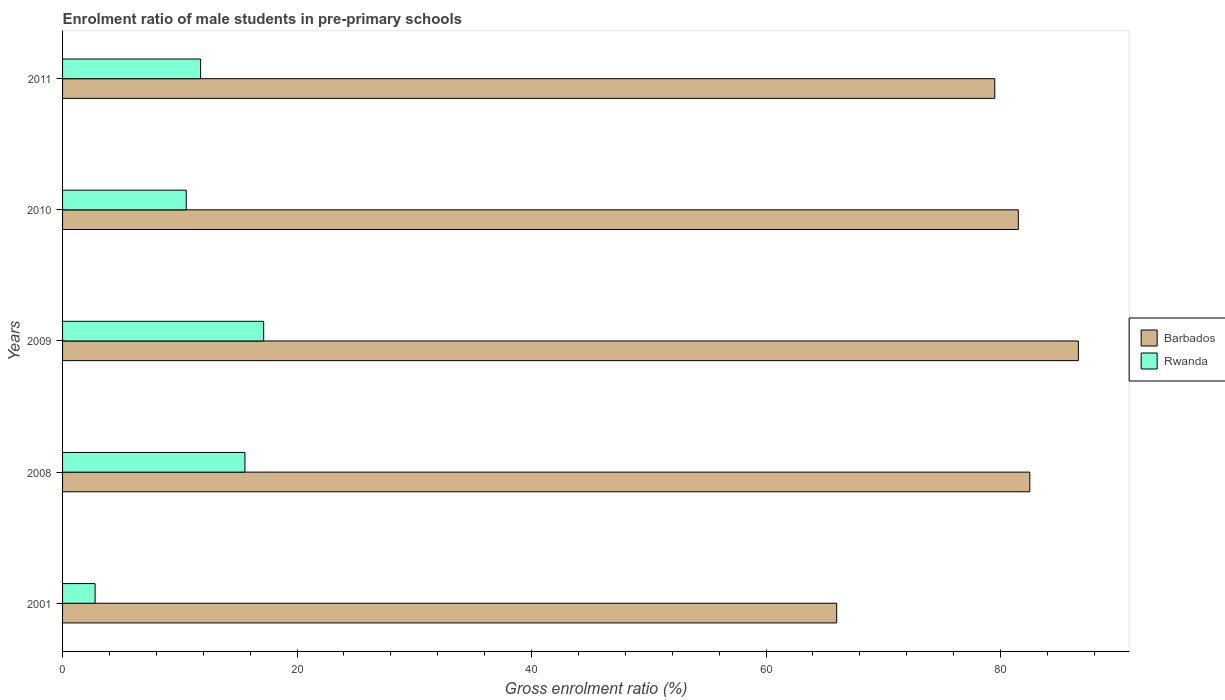How many different coloured bars are there?
Your response must be concise. 2. How many groups of bars are there?
Ensure brevity in your answer.  5. Are the number of bars per tick equal to the number of legend labels?
Offer a very short reply. Yes. What is the label of the 2nd group of bars from the top?
Ensure brevity in your answer.  2010. In how many cases, is the number of bars for a given year not equal to the number of legend labels?
Offer a very short reply. 0. What is the enrolment ratio of male students in pre-primary schools in Barbados in 2008?
Provide a succinct answer. 82.5. Across all years, what is the maximum enrolment ratio of male students in pre-primary schools in Rwanda?
Make the answer very short. 17.15. Across all years, what is the minimum enrolment ratio of male students in pre-primary schools in Rwanda?
Ensure brevity in your answer.  2.78. In which year was the enrolment ratio of male students in pre-primary schools in Barbados maximum?
Your response must be concise. 2009. What is the total enrolment ratio of male students in pre-primary schools in Rwanda in the graph?
Keep it short and to the point. 57.8. What is the difference between the enrolment ratio of male students in pre-primary schools in Rwanda in 2008 and that in 2011?
Provide a short and direct response. 3.78. What is the difference between the enrolment ratio of male students in pre-primary schools in Barbados in 2009 and the enrolment ratio of male students in pre-primary schools in Rwanda in 2008?
Offer a very short reply. 71.08. What is the average enrolment ratio of male students in pre-primary schools in Barbados per year?
Your answer should be very brief. 79.24. In the year 2009, what is the difference between the enrolment ratio of male students in pre-primary schools in Barbados and enrolment ratio of male students in pre-primary schools in Rwanda?
Offer a terse response. 69.48. What is the ratio of the enrolment ratio of male students in pre-primary schools in Rwanda in 2008 to that in 2010?
Make the answer very short. 1.47. Is the enrolment ratio of male students in pre-primary schools in Rwanda in 2008 less than that in 2009?
Give a very brief answer. Yes. What is the difference between the highest and the second highest enrolment ratio of male students in pre-primary schools in Barbados?
Make the answer very short. 4.14. What is the difference between the highest and the lowest enrolment ratio of male students in pre-primary schools in Barbados?
Keep it short and to the point. 20.61. What does the 1st bar from the top in 2008 represents?
Keep it short and to the point. Rwanda. What does the 2nd bar from the bottom in 2009 represents?
Provide a short and direct response. Rwanda. How many bars are there?
Your response must be concise. 10. How many years are there in the graph?
Ensure brevity in your answer.  5. Does the graph contain any zero values?
Your answer should be compact. No. Does the graph contain grids?
Your answer should be very brief. No. Where does the legend appear in the graph?
Provide a succinct answer. Center right. How many legend labels are there?
Offer a very short reply. 2. How are the legend labels stacked?
Keep it short and to the point. Vertical. What is the title of the graph?
Give a very brief answer. Enrolment ratio of male students in pre-primary schools. What is the label or title of the Y-axis?
Provide a succinct answer. Years. What is the Gross enrolment ratio (%) of Barbados in 2001?
Your answer should be very brief. 66.03. What is the Gross enrolment ratio (%) of Rwanda in 2001?
Give a very brief answer. 2.78. What is the Gross enrolment ratio (%) in Barbados in 2008?
Ensure brevity in your answer.  82.5. What is the Gross enrolment ratio (%) of Rwanda in 2008?
Your answer should be compact. 15.55. What is the Gross enrolment ratio (%) of Barbados in 2009?
Provide a short and direct response. 86.64. What is the Gross enrolment ratio (%) in Rwanda in 2009?
Keep it short and to the point. 17.15. What is the Gross enrolment ratio (%) in Barbados in 2010?
Keep it short and to the point. 81.52. What is the Gross enrolment ratio (%) in Rwanda in 2010?
Your answer should be compact. 10.55. What is the Gross enrolment ratio (%) in Barbados in 2011?
Your answer should be compact. 79.51. What is the Gross enrolment ratio (%) in Rwanda in 2011?
Provide a succinct answer. 11.77. Across all years, what is the maximum Gross enrolment ratio (%) of Barbados?
Keep it short and to the point. 86.64. Across all years, what is the maximum Gross enrolment ratio (%) in Rwanda?
Give a very brief answer. 17.15. Across all years, what is the minimum Gross enrolment ratio (%) of Barbados?
Give a very brief answer. 66.03. Across all years, what is the minimum Gross enrolment ratio (%) in Rwanda?
Your response must be concise. 2.78. What is the total Gross enrolment ratio (%) of Barbados in the graph?
Make the answer very short. 396.18. What is the total Gross enrolment ratio (%) in Rwanda in the graph?
Your response must be concise. 57.8. What is the difference between the Gross enrolment ratio (%) in Barbados in 2001 and that in 2008?
Provide a succinct answer. -16.47. What is the difference between the Gross enrolment ratio (%) in Rwanda in 2001 and that in 2008?
Your answer should be compact. -12.78. What is the difference between the Gross enrolment ratio (%) of Barbados in 2001 and that in 2009?
Offer a terse response. -20.61. What is the difference between the Gross enrolment ratio (%) in Rwanda in 2001 and that in 2009?
Your answer should be very brief. -14.38. What is the difference between the Gross enrolment ratio (%) of Barbados in 2001 and that in 2010?
Provide a short and direct response. -15.49. What is the difference between the Gross enrolment ratio (%) of Rwanda in 2001 and that in 2010?
Ensure brevity in your answer.  -7.77. What is the difference between the Gross enrolment ratio (%) of Barbados in 2001 and that in 2011?
Your response must be concise. -13.48. What is the difference between the Gross enrolment ratio (%) of Rwanda in 2001 and that in 2011?
Give a very brief answer. -9. What is the difference between the Gross enrolment ratio (%) of Barbados in 2008 and that in 2009?
Provide a succinct answer. -4.14. What is the difference between the Gross enrolment ratio (%) of Rwanda in 2008 and that in 2009?
Keep it short and to the point. -1.6. What is the difference between the Gross enrolment ratio (%) in Barbados in 2008 and that in 2010?
Provide a succinct answer. 0.98. What is the difference between the Gross enrolment ratio (%) in Rwanda in 2008 and that in 2010?
Provide a short and direct response. 5. What is the difference between the Gross enrolment ratio (%) of Barbados in 2008 and that in 2011?
Your answer should be compact. 2.99. What is the difference between the Gross enrolment ratio (%) in Rwanda in 2008 and that in 2011?
Provide a short and direct response. 3.78. What is the difference between the Gross enrolment ratio (%) of Barbados in 2009 and that in 2010?
Your answer should be very brief. 5.12. What is the difference between the Gross enrolment ratio (%) of Rwanda in 2009 and that in 2010?
Your answer should be very brief. 6.6. What is the difference between the Gross enrolment ratio (%) in Barbados in 2009 and that in 2011?
Keep it short and to the point. 7.13. What is the difference between the Gross enrolment ratio (%) of Rwanda in 2009 and that in 2011?
Your answer should be compact. 5.38. What is the difference between the Gross enrolment ratio (%) in Barbados in 2010 and that in 2011?
Your response must be concise. 2.01. What is the difference between the Gross enrolment ratio (%) in Rwanda in 2010 and that in 2011?
Offer a terse response. -1.22. What is the difference between the Gross enrolment ratio (%) in Barbados in 2001 and the Gross enrolment ratio (%) in Rwanda in 2008?
Your answer should be very brief. 50.47. What is the difference between the Gross enrolment ratio (%) in Barbados in 2001 and the Gross enrolment ratio (%) in Rwanda in 2009?
Your answer should be compact. 48.87. What is the difference between the Gross enrolment ratio (%) of Barbados in 2001 and the Gross enrolment ratio (%) of Rwanda in 2010?
Offer a terse response. 55.48. What is the difference between the Gross enrolment ratio (%) of Barbados in 2001 and the Gross enrolment ratio (%) of Rwanda in 2011?
Offer a very short reply. 54.25. What is the difference between the Gross enrolment ratio (%) of Barbados in 2008 and the Gross enrolment ratio (%) of Rwanda in 2009?
Offer a terse response. 65.34. What is the difference between the Gross enrolment ratio (%) of Barbados in 2008 and the Gross enrolment ratio (%) of Rwanda in 2010?
Your answer should be compact. 71.95. What is the difference between the Gross enrolment ratio (%) in Barbados in 2008 and the Gross enrolment ratio (%) in Rwanda in 2011?
Make the answer very short. 70.72. What is the difference between the Gross enrolment ratio (%) of Barbados in 2009 and the Gross enrolment ratio (%) of Rwanda in 2010?
Your response must be concise. 76.09. What is the difference between the Gross enrolment ratio (%) in Barbados in 2009 and the Gross enrolment ratio (%) in Rwanda in 2011?
Provide a succinct answer. 74.86. What is the difference between the Gross enrolment ratio (%) of Barbados in 2010 and the Gross enrolment ratio (%) of Rwanda in 2011?
Your answer should be very brief. 69.74. What is the average Gross enrolment ratio (%) in Barbados per year?
Provide a succinct answer. 79.24. What is the average Gross enrolment ratio (%) of Rwanda per year?
Keep it short and to the point. 11.56. In the year 2001, what is the difference between the Gross enrolment ratio (%) of Barbados and Gross enrolment ratio (%) of Rwanda?
Offer a terse response. 63.25. In the year 2008, what is the difference between the Gross enrolment ratio (%) of Barbados and Gross enrolment ratio (%) of Rwanda?
Keep it short and to the point. 66.94. In the year 2009, what is the difference between the Gross enrolment ratio (%) in Barbados and Gross enrolment ratio (%) in Rwanda?
Ensure brevity in your answer.  69.48. In the year 2010, what is the difference between the Gross enrolment ratio (%) of Barbados and Gross enrolment ratio (%) of Rwanda?
Give a very brief answer. 70.97. In the year 2011, what is the difference between the Gross enrolment ratio (%) of Barbados and Gross enrolment ratio (%) of Rwanda?
Keep it short and to the point. 67.73. What is the ratio of the Gross enrolment ratio (%) of Barbados in 2001 to that in 2008?
Offer a terse response. 0.8. What is the ratio of the Gross enrolment ratio (%) in Rwanda in 2001 to that in 2008?
Offer a very short reply. 0.18. What is the ratio of the Gross enrolment ratio (%) in Barbados in 2001 to that in 2009?
Make the answer very short. 0.76. What is the ratio of the Gross enrolment ratio (%) in Rwanda in 2001 to that in 2009?
Ensure brevity in your answer.  0.16. What is the ratio of the Gross enrolment ratio (%) in Barbados in 2001 to that in 2010?
Your answer should be very brief. 0.81. What is the ratio of the Gross enrolment ratio (%) of Rwanda in 2001 to that in 2010?
Your response must be concise. 0.26. What is the ratio of the Gross enrolment ratio (%) in Barbados in 2001 to that in 2011?
Your response must be concise. 0.83. What is the ratio of the Gross enrolment ratio (%) in Rwanda in 2001 to that in 2011?
Make the answer very short. 0.24. What is the ratio of the Gross enrolment ratio (%) in Barbados in 2008 to that in 2009?
Ensure brevity in your answer.  0.95. What is the ratio of the Gross enrolment ratio (%) in Rwanda in 2008 to that in 2009?
Keep it short and to the point. 0.91. What is the ratio of the Gross enrolment ratio (%) in Barbados in 2008 to that in 2010?
Provide a succinct answer. 1.01. What is the ratio of the Gross enrolment ratio (%) of Rwanda in 2008 to that in 2010?
Your answer should be very brief. 1.47. What is the ratio of the Gross enrolment ratio (%) of Barbados in 2008 to that in 2011?
Your answer should be compact. 1.04. What is the ratio of the Gross enrolment ratio (%) of Rwanda in 2008 to that in 2011?
Keep it short and to the point. 1.32. What is the ratio of the Gross enrolment ratio (%) in Barbados in 2009 to that in 2010?
Your answer should be compact. 1.06. What is the ratio of the Gross enrolment ratio (%) in Rwanda in 2009 to that in 2010?
Your answer should be compact. 1.63. What is the ratio of the Gross enrolment ratio (%) in Barbados in 2009 to that in 2011?
Your response must be concise. 1.09. What is the ratio of the Gross enrolment ratio (%) in Rwanda in 2009 to that in 2011?
Keep it short and to the point. 1.46. What is the ratio of the Gross enrolment ratio (%) of Barbados in 2010 to that in 2011?
Ensure brevity in your answer.  1.03. What is the ratio of the Gross enrolment ratio (%) in Rwanda in 2010 to that in 2011?
Your answer should be very brief. 0.9. What is the difference between the highest and the second highest Gross enrolment ratio (%) in Barbados?
Make the answer very short. 4.14. What is the difference between the highest and the second highest Gross enrolment ratio (%) of Rwanda?
Make the answer very short. 1.6. What is the difference between the highest and the lowest Gross enrolment ratio (%) of Barbados?
Your answer should be compact. 20.61. What is the difference between the highest and the lowest Gross enrolment ratio (%) in Rwanda?
Provide a succinct answer. 14.38. 